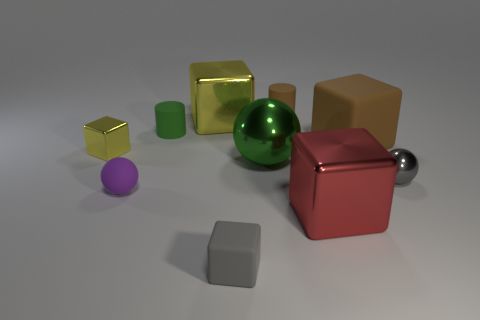Subtract all brown rubber cubes. How many cubes are left? 4 Subtract all purple balls. How many balls are left? 2 Subtract all cyan spheres. How many yellow cubes are left? 2 Subtract 2 spheres. How many spheres are left? 1 Subtract all cylinders. How many objects are left? 8 Subtract all gray cylinders. Subtract all brown cubes. How many cylinders are left? 2 Subtract all small green things. Subtract all red shiny blocks. How many objects are left? 8 Add 6 tiny brown rubber cylinders. How many tiny brown rubber cylinders are left? 7 Add 6 small gray matte things. How many small gray matte things exist? 7 Subtract 0 blue cylinders. How many objects are left? 10 